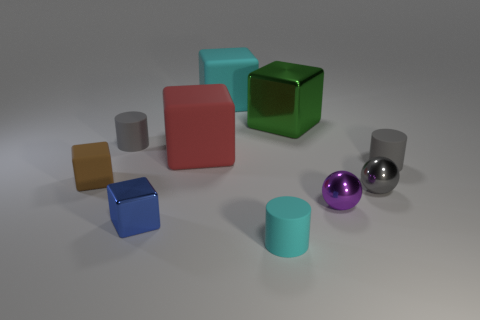There is a large thing that is the same material as the cyan cube; what is its color?
Your response must be concise. Red. What number of large objects are behind the small gray matte object that is to the left of the small cyan thing?
Offer a terse response. 2. There is a cube that is both left of the big red rubber thing and behind the small gray metal thing; what material is it made of?
Your answer should be compact. Rubber. There is a small gray matte object behind the red object; is it the same shape as the tiny cyan matte thing?
Your answer should be compact. Yes. Are there fewer blue cubes than tiny purple metal blocks?
Your answer should be very brief. No. How many large metallic things have the same color as the tiny shiny block?
Ensure brevity in your answer.  0. Are there more blue metallic spheres than tiny cyan cylinders?
Offer a very short reply. No. What is the size of the brown object that is the same shape as the red matte object?
Make the answer very short. Small. Is the green block made of the same material as the tiny block in front of the brown block?
Your response must be concise. Yes. How many objects are either blue metallic cubes or big cyan rubber things?
Make the answer very short. 2. 